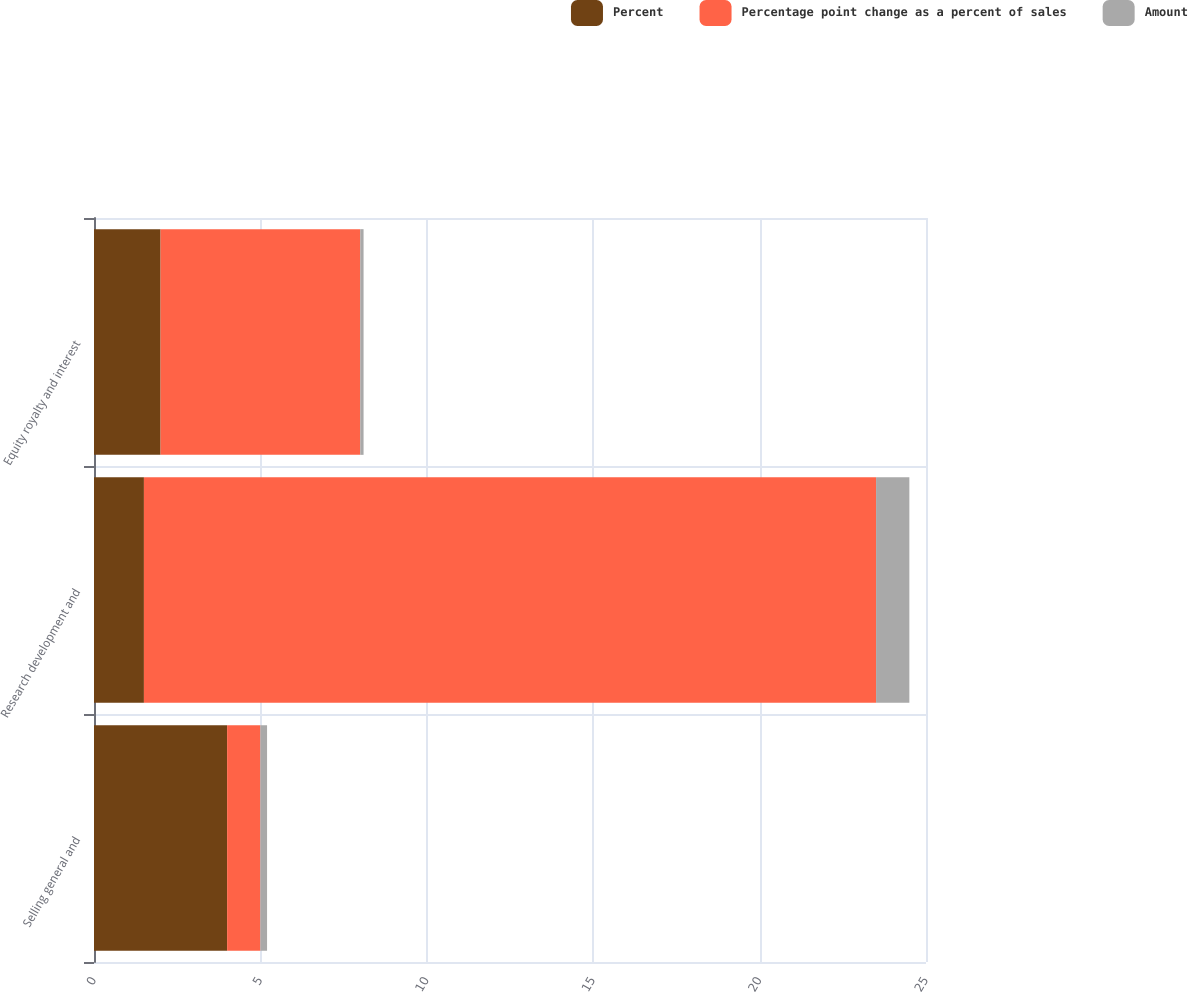<chart> <loc_0><loc_0><loc_500><loc_500><stacked_bar_chart><ecel><fcel>Selling general and<fcel>Research development and<fcel>Equity royalty and interest<nl><fcel>Percent<fcel>4<fcel>1.5<fcel>2<nl><fcel>Percentage point change as a percent of sales<fcel>1<fcel>22<fcel>6<nl><fcel>Amount<fcel>0.2<fcel>1<fcel>0.1<nl></chart> 